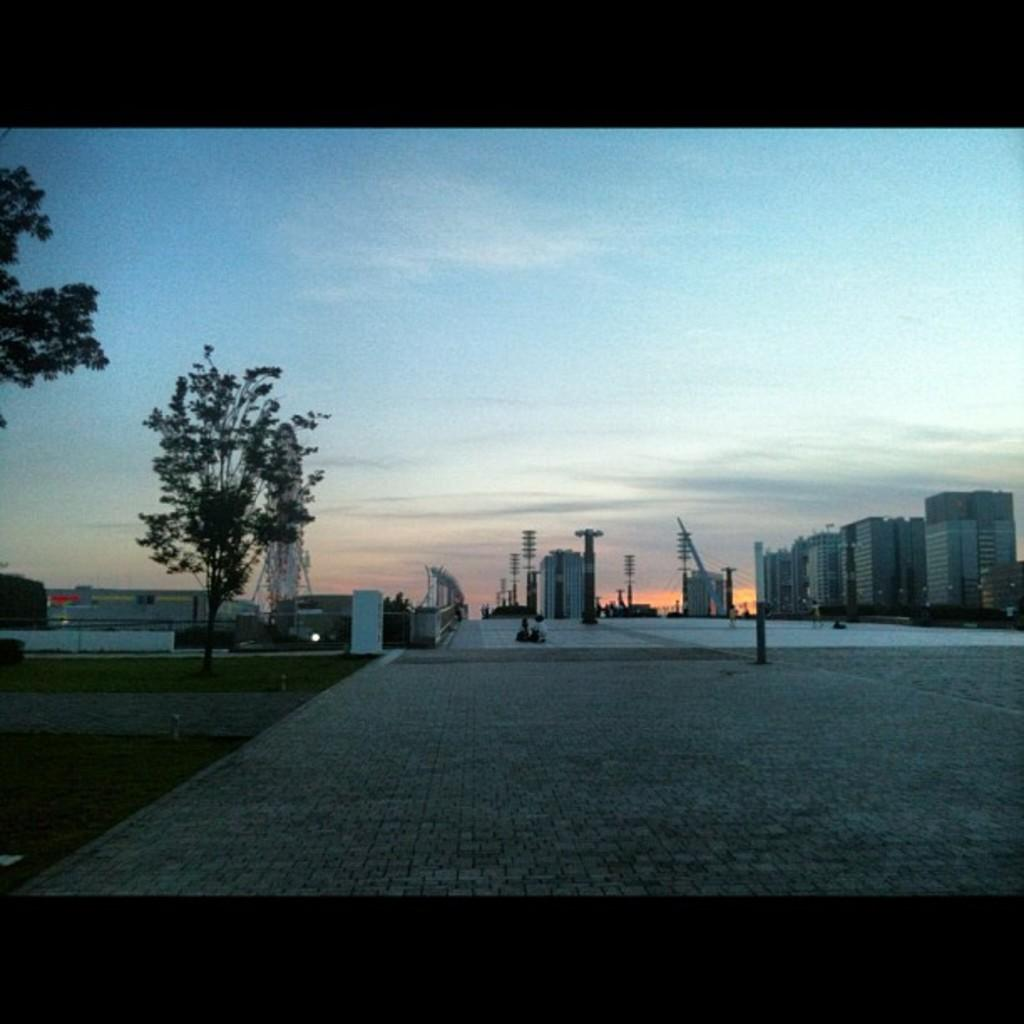How many trees can be seen in the image? There are two trees in the image. What is the terrain in the front of the image? There is an open grass ground in the front of the image. What can be seen in the background of the image? There are buildings, poles, and people in the background of the image. What is visible in the sky in the background of the image? There are clouds and the sky visible in the background of the image. What type of machine is being operated by the people in the image? There is no machine visible in the image; it only shows two trees, an open grass ground, buildings, poles, people, clouds, and the sky. Can you tell me which wrist the person in the image is wearing a watch on? There is no person wearing a watch in the image. 